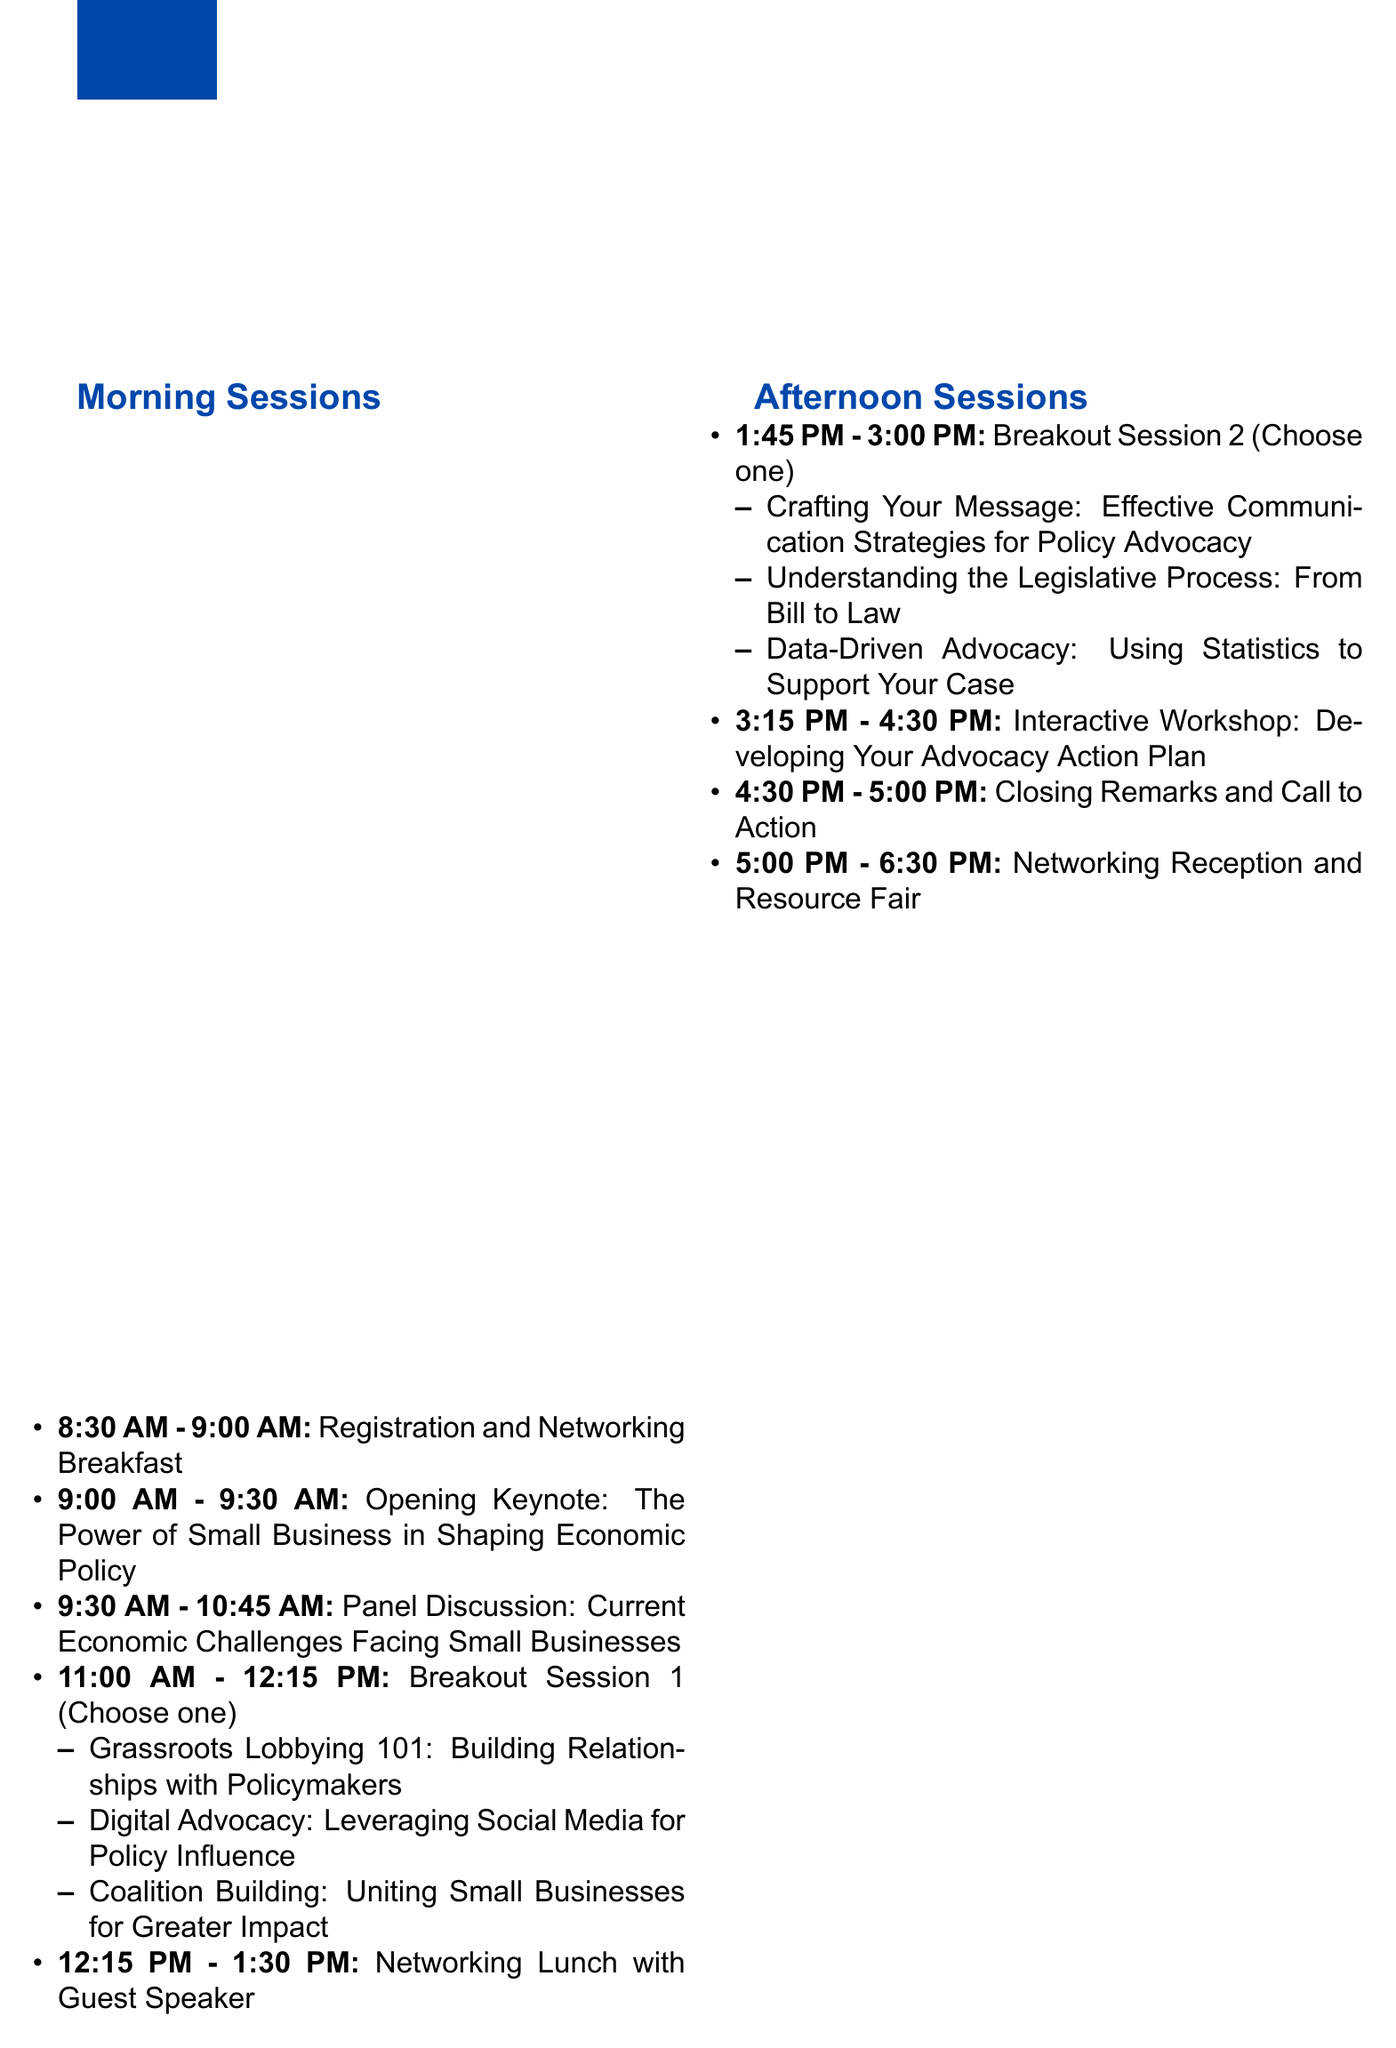What is the date of the workshop? The date of the workshop is specified in the document as September 15, 2023.
Answer: September 15, 2023 Who is the speaker for the opening keynote? The speaker for the opening keynote is mentioned in the document as Jane Smith, CEO of National Federation of Independent Business.
Answer: Jane Smith What time does the networking lunch start? The start time for the networking lunch is given in the document as 12:15 PM.
Answer: 12:15 PM How many breakout sessions are scheduled? The document lists two breakout sessions, indicating the number of scheduled sessions.
Answer: Two What is the title of the first breakout session option? The first breakout session option is listed as "Grassroots Lobbying 101: Building Relationships with Policymakers".
Answer: Grassroots Lobbying 101: Building Relationships with Policymakers Who is facilitating the interactive workshop? The facilitator for the interactive workshop is named in the document as Thomas Baker, Founder of Small Business Advocacy Institute.
Answer: Thomas Baker What is the duration of the networking reception? The document states that the networking reception lasts from 5:00 PM to 6:30 PM, indicating its duration.
Answer: 1 hour 30 minutes What is provided as an additional resource for attendees? The document lists several additional resources, one of which is the "Small Business Advocacy Toolkit (digital download)".
Answer: Small Business Advocacy Toolkit (digital download) What is the venue for the workshop? The venue for the workshop is detailed in the document as Grand Hyatt Washington, 1000 H Street NW, Washington, DC 20001.
Answer: Grand Hyatt Washington, 1000 H Street NW, Washington, DC 20001 